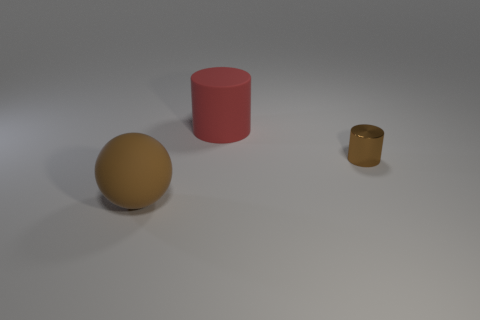Subtract 1 cylinders. How many cylinders are left? 1 Subtract all gray cylinders. Subtract all purple balls. How many cylinders are left? 2 Subtract all yellow cubes. How many blue cylinders are left? 0 Subtract all tiny brown shiny cylinders. Subtract all tiny gray metallic things. How many objects are left? 2 Add 2 brown cylinders. How many brown cylinders are left? 3 Add 3 small purple cylinders. How many small purple cylinders exist? 3 Add 3 green balls. How many objects exist? 6 Subtract all red cylinders. How many cylinders are left? 1 Subtract 0 yellow cylinders. How many objects are left? 3 Subtract all spheres. How many objects are left? 2 